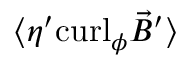<formula> <loc_0><loc_0><loc_500><loc_500>\langle \eta ^ { \prime } c u r l _ { \phi } { \vec { B } } ^ { \prime } \rangle</formula> 